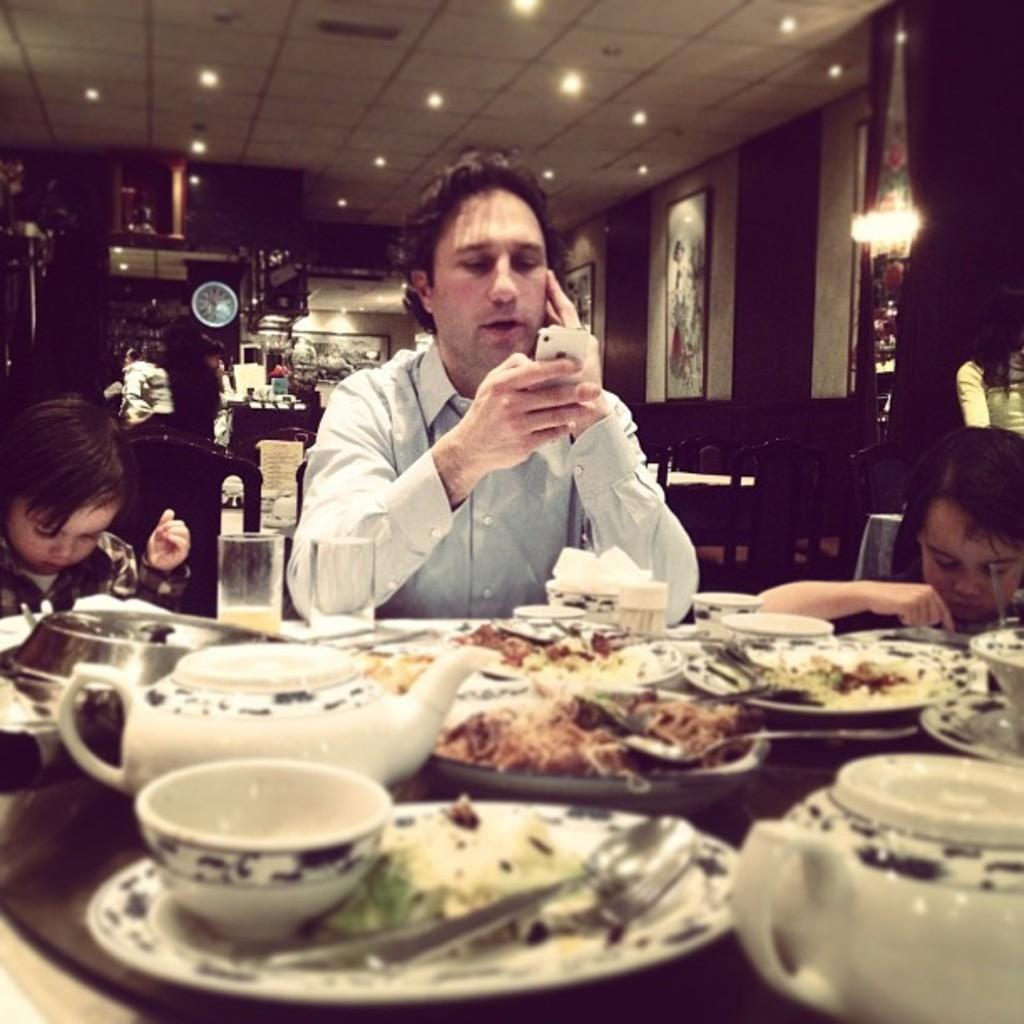Who is present in the image? There is a man in the image. What is the man doing in the image? The man is sitting on a chair. What objects can be seen on the table in the image? There is a kettle, a plate, a spoon, and food items on the table. What type of sock is the man wearing in the image? There is no sock visible in the image; the man is wearing pants and shoes. What offer is the man making to the viewer in the image? There is no offer being made in the image; the man is simply sitting on a chair. 